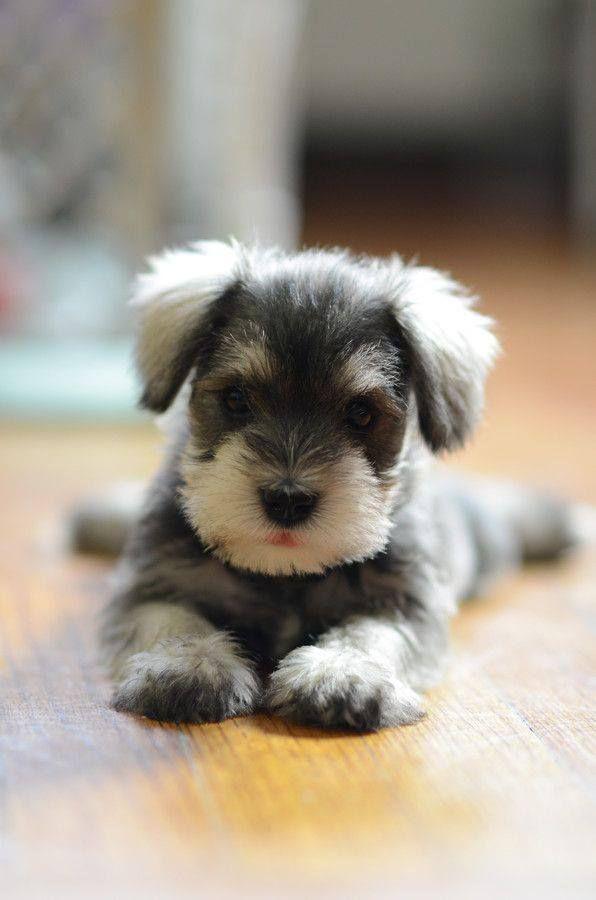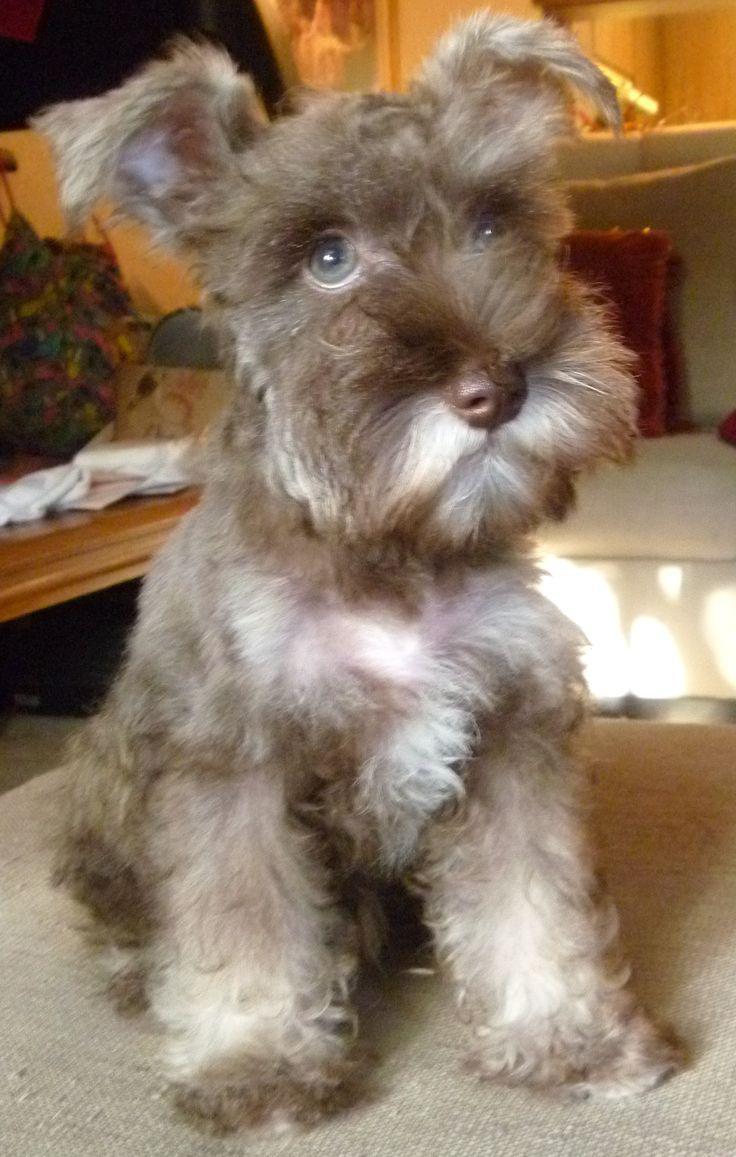The first image is the image on the left, the second image is the image on the right. Analyze the images presented: Is the assertion "There is at least collar in the image on the left." valid? Answer yes or no. No. 